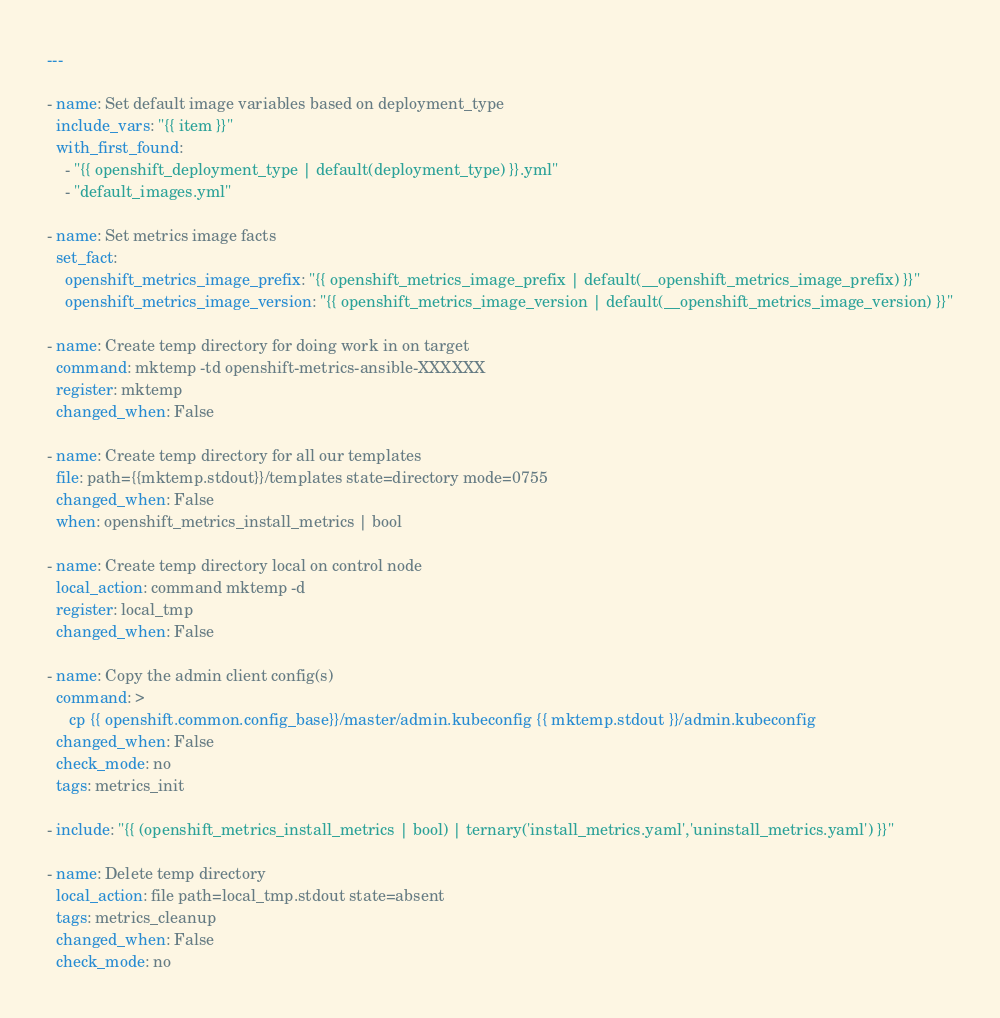<code> <loc_0><loc_0><loc_500><loc_500><_YAML_>---

- name: Set default image variables based on deployment_type
  include_vars: "{{ item }}"
  with_first_found:
    - "{{ openshift_deployment_type | default(deployment_type) }}.yml"
    - "default_images.yml"

- name: Set metrics image facts
  set_fact:
    openshift_metrics_image_prefix: "{{ openshift_metrics_image_prefix | default(__openshift_metrics_image_prefix) }}"
    openshift_metrics_image_version: "{{ openshift_metrics_image_version | default(__openshift_metrics_image_version) }}"

- name: Create temp directory for doing work in on target
  command: mktemp -td openshift-metrics-ansible-XXXXXX
  register: mktemp
  changed_when: False

- name: Create temp directory for all our templates
  file: path={{mktemp.stdout}}/templates state=directory mode=0755
  changed_when: False
  when: openshift_metrics_install_metrics | bool

- name: Create temp directory local on control node
  local_action: command mktemp -d
  register: local_tmp
  changed_when: False

- name: Copy the admin client config(s)
  command: >
     cp {{ openshift.common.config_base}}/master/admin.kubeconfig {{ mktemp.stdout }}/admin.kubeconfig
  changed_when: False
  check_mode: no
  tags: metrics_init

- include: "{{ (openshift_metrics_install_metrics | bool) | ternary('install_metrics.yaml','uninstall_metrics.yaml') }}"

- name: Delete temp directory
  local_action: file path=local_tmp.stdout state=absent
  tags: metrics_cleanup
  changed_when: False
  check_mode: no
</code> 